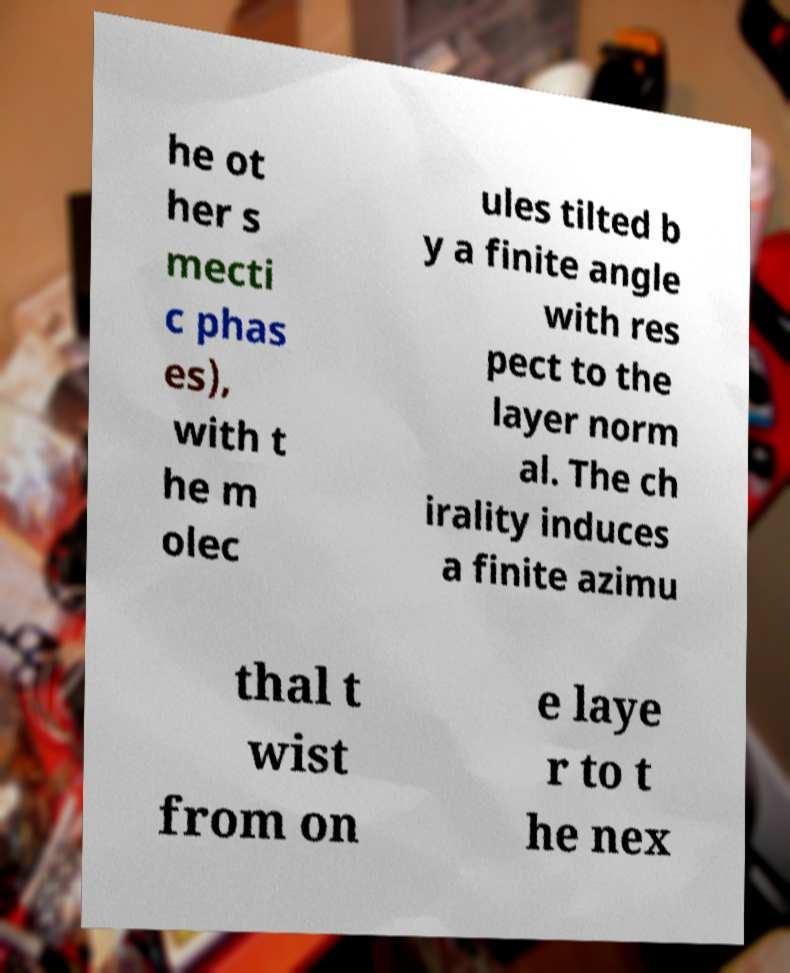Could you extract and type out the text from this image? he ot her s mecti c phas es), with t he m olec ules tilted b y a finite angle with res pect to the layer norm al. The ch irality induces a finite azimu thal t wist from on e laye r to t he nex 